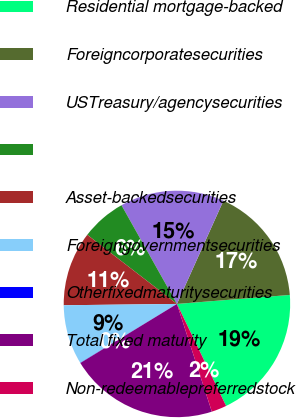<chart> <loc_0><loc_0><loc_500><loc_500><pie_chart><fcel>Residential mortgage-backed<fcel>Foreigncorporatesecurities<fcel>USTreasury/agencysecurities<fcel>Unnamed: 3<fcel>Asset-backedsecurities<fcel>Foreigngovernmentsecurities<fcel>Otherfixedmaturitysecurities<fcel>Total fixed maturity<fcel>Non-redeemablepreferredstock<nl><fcel>19.12%<fcel>17.0%<fcel>14.88%<fcel>6.4%<fcel>10.64%<fcel>8.52%<fcel>0.03%<fcel>21.25%<fcel>2.16%<nl></chart> 